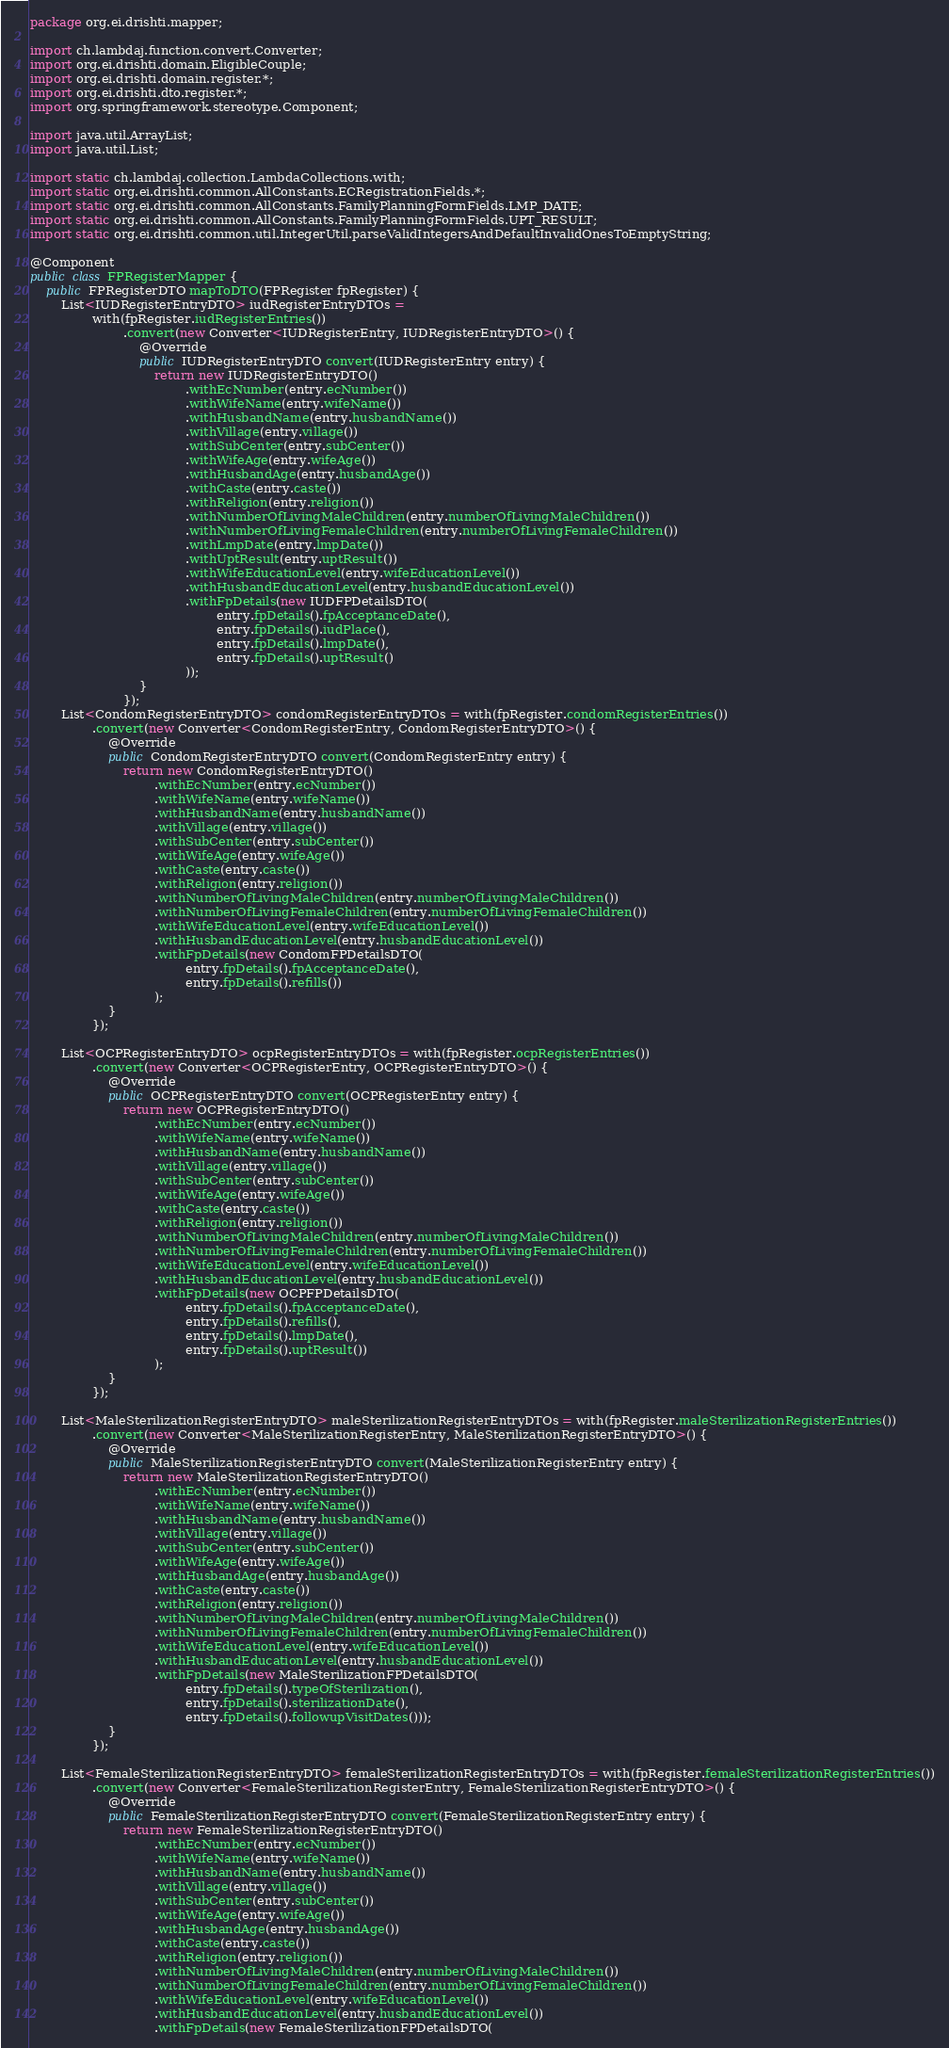<code> <loc_0><loc_0><loc_500><loc_500><_Java_>package org.ei.drishti.mapper;

import ch.lambdaj.function.convert.Converter;
import org.ei.drishti.domain.EligibleCouple;
import org.ei.drishti.domain.register.*;
import org.ei.drishti.dto.register.*;
import org.springframework.stereotype.Component;

import java.util.ArrayList;
import java.util.List;

import static ch.lambdaj.collection.LambdaCollections.with;
import static org.ei.drishti.common.AllConstants.ECRegistrationFields.*;
import static org.ei.drishti.common.AllConstants.FamilyPlanningFormFields.LMP_DATE;
import static org.ei.drishti.common.AllConstants.FamilyPlanningFormFields.UPT_RESULT;
import static org.ei.drishti.common.util.IntegerUtil.parseValidIntegersAndDefaultInvalidOnesToEmptyString;

@Component
public class FPRegisterMapper {
    public FPRegisterDTO mapToDTO(FPRegister fpRegister) {
        List<IUDRegisterEntryDTO> iudRegisterEntryDTOs =
                with(fpRegister.iudRegisterEntries())
                        .convert(new Converter<IUDRegisterEntry, IUDRegisterEntryDTO>() {
                            @Override
                            public IUDRegisterEntryDTO convert(IUDRegisterEntry entry) {
                                return new IUDRegisterEntryDTO()
                                        .withEcNumber(entry.ecNumber())
                                        .withWifeName(entry.wifeName())
                                        .withHusbandName(entry.husbandName())
                                        .withVillage(entry.village())
                                        .withSubCenter(entry.subCenter())
                                        .withWifeAge(entry.wifeAge())
                                        .withHusbandAge(entry.husbandAge())
                                        .withCaste(entry.caste())
                                        .withReligion(entry.religion())
                                        .withNumberOfLivingMaleChildren(entry.numberOfLivingMaleChildren())
                                        .withNumberOfLivingFemaleChildren(entry.numberOfLivingFemaleChildren())
                                        .withLmpDate(entry.lmpDate())
                                        .withUptResult(entry.uptResult())
                                        .withWifeEducationLevel(entry.wifeEducationLevel())
                                        .withHusbandEducationLevel(entry.husbandEducationLevel())
                                        .withFpDetails(new IUDFPDetailsDTO(
                                                entry.fpDetails().fpAcceptanceDate(),
                                                entry.fpDetails().iudPlace(),
                                                entry.fpDetails().lmpDate(),
                                                entry.fpDetails().uptResult()
                                        ));
                            }
                        });
        List<CondomRegisterEntryDTO> condomRegisterEntryDTOs = with(fpRegister.condomRegisterEntries())
                .convert(new Converter<CondomRegisterEntry, CondomRegisterEntryDTO>() {
                    @Override
                    public CondomRegisterEntryDTO convert(CondomRegisterEntry entry) {
                        return new CondomRegisterEntryDTO()
                                .withEcNumber(entry.ecNumber())
                                .withWifeName(entry.wifeName())
                                .withHusbandName(entry.husbandName())
                                .withVillage(entry.village())
                                .withSubCenter(entry.subCenter())
                                .withWifeAge(entry.wifeAge())
                                .withCaste(entry.caste())
                                .withReligion(entry.religion())
                                .withNumberOfLivingMaleChildren(entry.numberOfLivingMaleChildren())
                                .withNumberOfLivingFemaleChildren(entry.numberOfLivingFemaleChildren())
                                .withWifeEducationLevel(entry.wifeEducationLevel())
                                .withHusbandEducationLevel(entry.husbandEducationLevel())
                                .withFpDetails(new CondomFPDetailsDTO(
                                        entry.fpDetails().fpAcceptanceDate(),
                                        entry.fpDetails().refills())
                                );
                    }
                });

        List<OCPRegisterEntryDTO> ocpRegisterEntryDTOs = with(fpRegister.ocpRegisterEntries())
                .convert(new Converter<OCPRegisterEntry, OCPRegisterEntryDTO>() {
                    @Override
                    public OCPRegisterEntryDTO convert(OCPRegisterEntry entry) {
                        return new OCPRegisterEntryDTO()
                                .withEcNumber(entry.ecNumber())
                                .withWifeName(entry.wifeName())
                                .withHusbandName(entry.husbandName())
                                .withVillage(entry.village())
                                .withSubCenter(entry.subCenter())
                                .withWifeAge(entry.wifeAge())
                                .withCaste(entry.caste())
                                .withReligion(entry.religion())
                                .withNumberOfLivingMaleChildren(entry.numberOfLivingMaleChildren())
                                .withNumberOfLivingFemaleChildren(entry.numberOfLivingFemaleChildren())
                                .withWifeEducationLevel(entry.wifeEducationLevel())
                                .withHusbandEducationLevel(entry.husbandEducationLevel())
                                .withFpDetails(new OCPFPDetailsDTO(
                                        entry.fpDetails().fpAcceptanceDate(),
                                        entry.fpDetails().refills(),
                                        entry.fpDetails().lmpDate(),
                                        entry.fpDetails().uptResult())
                                );
                    }
                });

        List<MaleSterilizationRegisterEntryDTO> maleSterilizationRegisterEntryDTOs = with(fpRegister.maleSterilizationRegisterEntries())
                .convert(new Converter<MaleSterilizationRegisterEntry, MaleSterilizationRegisterEntryDTO>() {
                    @Override
                    public MaleSterilizationRegisterEntryDTO convert(MaleSterilizationRegisterEntry entry) {
                        return new MaleSterilizationRegisterEntryDTO()
                                .withEcNumber(entry.ecNumber())
                                .withWifeName(entry.wifeName())
                                .withHusbandName(entry.husbandName())
                                .withVillage(entry.village())
                                .withSubCenter(entry.subCenter())
                                .withWifeAge(entry.wifeAge())
                                .withHusbandAge(entry.husbandAge())
                                .withCaste(entry.caste())
                                .withReligion(entry.religion())
                                .withNumberOfLivingMaleChildren(entry.numberOfLivingMaleChildren())
                                .withNumberOfLivingFemaleChildren(entry.numberOfLivingFemaleChildren())
                                .withWifeEducationLevel(entry.wifeEducationLevel())
                                .withHusbandEducationLevel(entry.husbandEducationLevel())
                                .withFpDetails(new MaleSterilizationFPDetailsDTO(
                                        entry.fpDetails().typeOfSterilization(),
                                        entry.fpDetails().sterilizationDate(),
                                        entry.fpDetails().followupVisitDates()));
                    }
                });

        List<FemaleSterilizationRegisterEntryDTO> femaleSterilizationRegisterEntryDTOs = with(fpRegister.femaleSterilizationRegisterEntries())
                .convert(new Converter<FemaleSterilizationRegisterEntry, FemaleSterilizationRegisterEntryDTO>() {
                    @Override
                    public FemaleSterilizationRegisterEntryDTO convert(FemaleSterilizationRegisterEntry entry) {
                        return new FemaleSterilizationRegisterEntryDTO()
                                .withEcNumber(entry.ecNumber())
                                .withWifeName(entry.wifeName())
                                .withHusbandName(entry.husbandName())
                                .withVillage(entry.village())
                                .withSubCenter(entry.subCenter())
                                .withWifeAge(entry.wifeAge())
                                .withHusbandAge(entry.husbandAge())
                                .withCaste(entry.caste())
                                .withReligion(entry.religion())
                                .withNumberOfLivingMaleChildren(entry.numberOfLivingMaleChildren())
                                .withNumberOfLivingFemaleChildren(entry.numberOfLivingFemaleChildren())
                                .withWifeEducationLevel(entry.wifeEducationLevel())
                                .withHusbandEducationLevel(entry.husbandEducationLevel())
                                .withFpDetails(new FemaleSterilizationFPDetailsDTO(</code> 